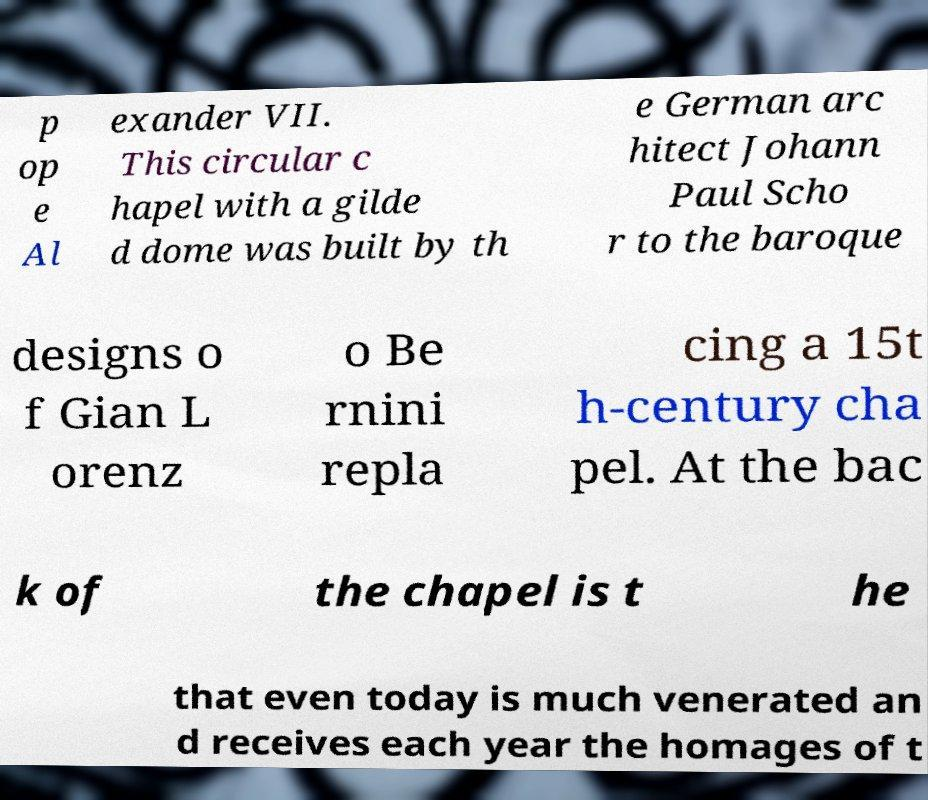Could you extract and type out the text from this image? p op e Al exander VII. This circular c hapel with a gilde d dome was built by th e German arc hitect Johann Paul Scho r to the baroque designs o f Gian L orenz o Be rnini repla cing a 15t h-century cha pel. At the bac k of the chapel is t he that even today is much venerated an d receives each year the homages of t 